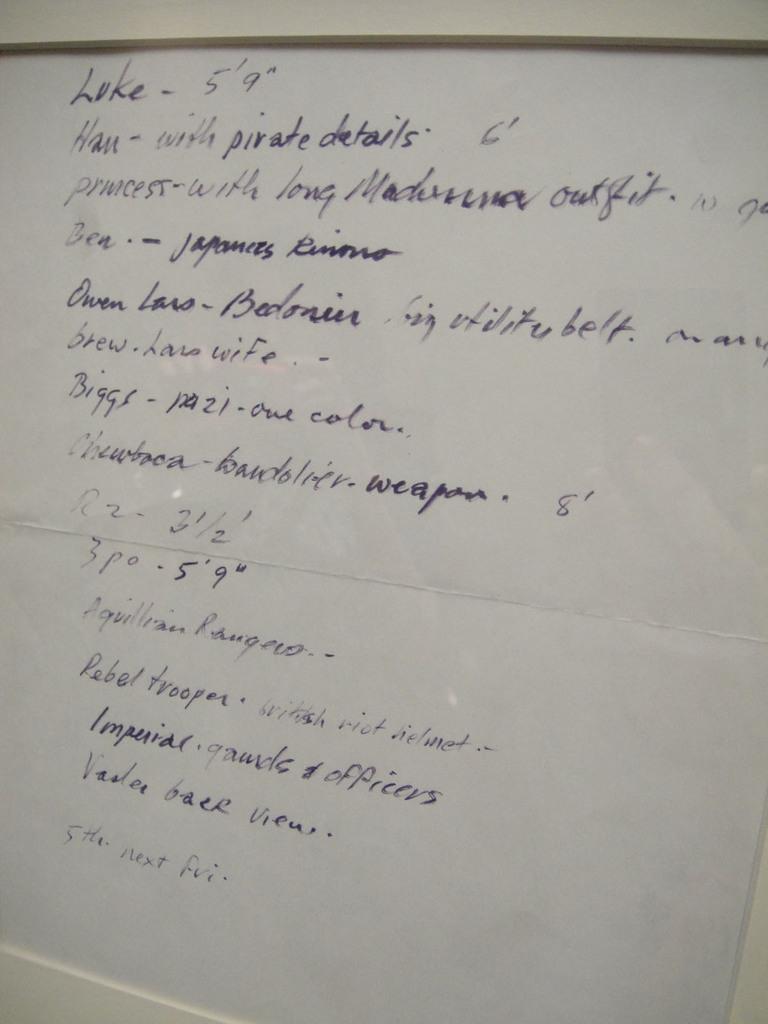What will the rebel trooper be wearing?
Provide a short and direct response. British riot helmet. What style writing is on the board?
Your response must be concise. Cursive. 